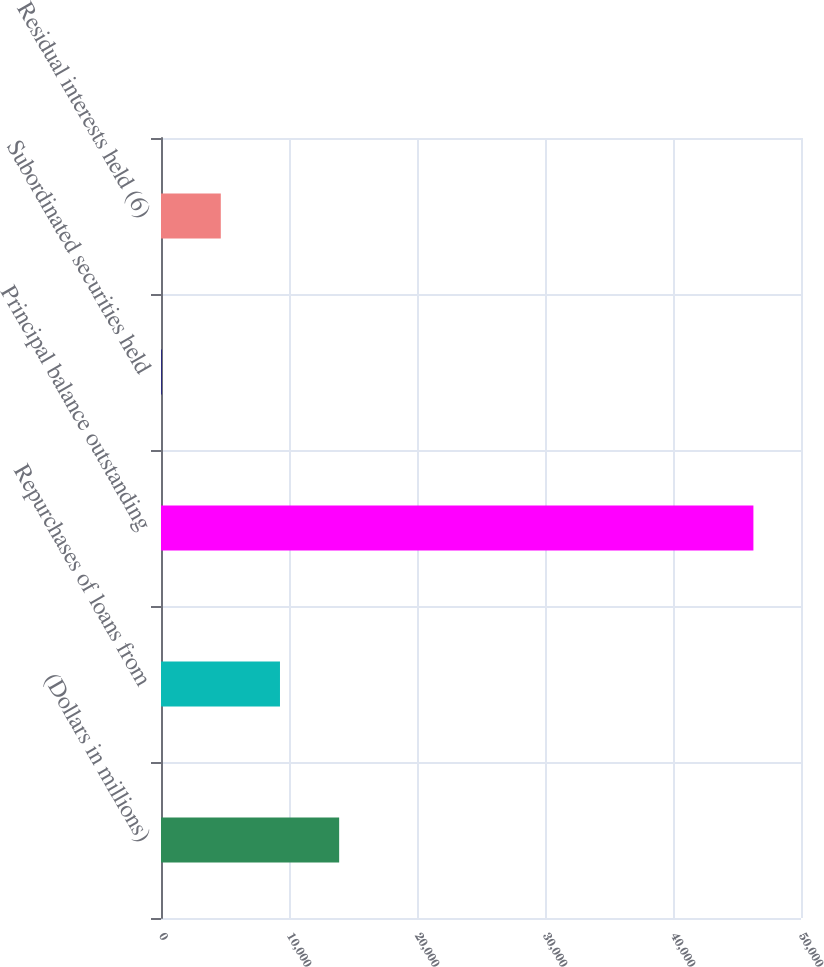Convert chart to OTSL. <chart><loc_0><loc_0><loc_500><loc_500><bar_chart><fcel>(Dollars in millions)<fcel>Repurchases of loans from<fcel>Principal balance outstanding<fcel>Subordinated securities held<fcel>Residual interests held (6)<nl><fcel>13918.2<fcel>9294.8<fcel>46282<fcel>48<fcel>4671.4<nl></chart> 